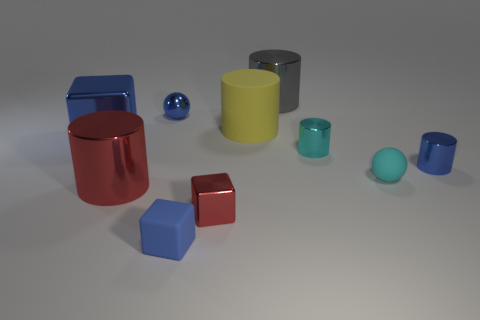How many yellow things have the same shape as the tiny red shiny thing?
Make the answer very short. 0. How many objects are either cyan metal balls or big things in front of the yellow rubber cylinder?
Keep it short and to the point. 2. There is a tiny matte cube; is its color the same as the metallic cylinder in front of the rubber sphere?
Keep it short and to the point. No. There is a blue object that is both in front of the tiny cyan metal cylinder and left of the big gray cylinder; what size is it?
Your response must be concise. Small. Are there any small red metallic blocks on the right side of the blue metallic cylinder?
Your answer should be very brief. No. There is a big red metal cylinder that is behind the tiny blue rubber object; is there a large blue metal cube that is on the right side of it?
Your answer should be compact. No. Is the number of yellow cylinders in front of the red cylinder the same as the number of tiny things to the right of the large gray thing?
Give a very brief answer. No. There is a big cube that is the same material as the blue cylinder; what color is it?
Keep it short and to the point. Blue. Are there any other red cylinders made of the same material as the large red cylinder?
Provide a succinct answer. No. What number of things are either big blocks or cyan metal cylinders?
Ensure brevity in your answer.  2. 